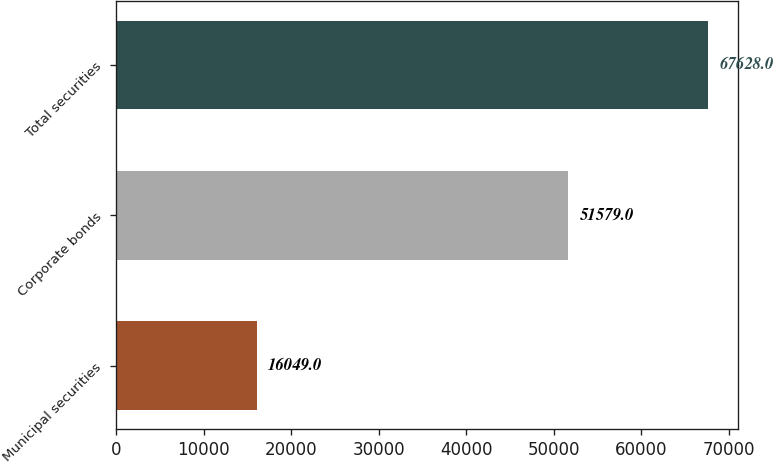<chart> <loc_0><loc_0><loc_500><loc_500><bar_chart><fcel>Municipal securities<fcel>Corporate bonds<fcel>Total securities<nl><fcel>16049<fcel>51579<fcel>67628<nl></chart> 